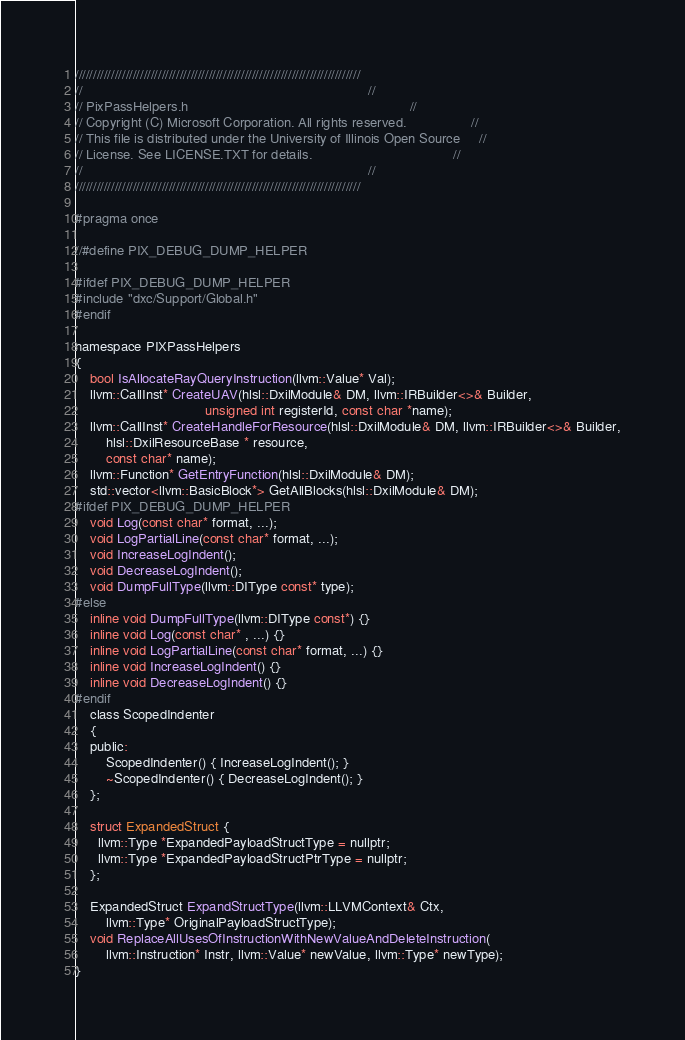<code> <loc_0><loc_0><loc_500><loc_500><_C_>///////////////////////////////////////////////////////////////////////////////
//                                                                           //
// PixPassHelpers.h  														 //
// Copyright (C) Microsoft Corporation. All rights reserved.                 //
// This file is distributed under the University of Illinois Open Source     //
// License. See LICENSE.TXT for details.                                     //
//                                                                           //
///////////////////////////////////////////////////////////////////////////////

#pragma once

//#define PIX_DEBUG_DUMP_HELPER

#ifdef PIX_DEBUG_DUMP_HELPER
#include "dxc/Support/Global.h"
#endif

namespace PIXPassHelpers
{
	bool IsAllocateRayQueryInstruction(llvm::Value* Val);
    llvm::CallInst* CreateUAV(hlsl::DxilModule& DM, llvm::IRBuilder<>& Builder,
                                  unsigned int registerId, const char *name);
    llvm::CallInst* CreateHandleForResource(hlsl::DxilModule& DM, llvm::IRBuilder<>& Builder,
        hlsl::DxilResourceBase * resource,
        const char* name);
    llvm::Function* GetEntryFunction(hlsl::DxilModule& DM);
    std::vector<llvm::BasicBlock*> GetAllBlocks(hlsl::DxilModule& DM);
#ifdef PIX_DEBUG_DUMP_HELPER
    void Log(const char* format, ...);
    void LogPartialLine(const char* format, ...);
    void IncreaseLogIndent();
    void DecreaseLogIndent();
    void DumpFullType(llvm::DIType const* type);
#else
    inline void DumpFullType(llvm::DIType const*) {}
    inline void Log(const char* , ...) {}
    inline void LogPartialLine(const char* format, ...) {}
    inline void IncreaseLogIndent() {}
    inline void DecreaseLogIndent() {}
#endif
    class ScopedIndenter
    {
    public:
        ScopedIndenter() { IncreaseLogIndent(); }
        ~ScopedIndenter() { DecreaseLogIndent(); }
    };

    struct ExpandedStruct {
      llvm::Type *ExpandedPayloadStructType = nullptr;
      llvm::Type *ExpandedPayloadStructPtrType = nullptr;
    };

    ExpandedStruct ExpandStructType(llvm::LLVMContext& Ctx,
        llvm::Type* OriginalPayloadStructType);
    void ReplaceAllUsesOfInstructionWithNewValueAndDeleteInstruction(
        llvm::Instruction* Instr, llvm::Value* newValue, llvm::Type* newType);
}</code> 